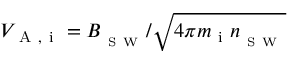<formula> <loc_0><loc_0><loc_500><loc_500>V _ { A , i } = B _ { _ { S W } } / \sqrt { 4 \pi m _ { i } n _ { _ { S W } } }</formula> 